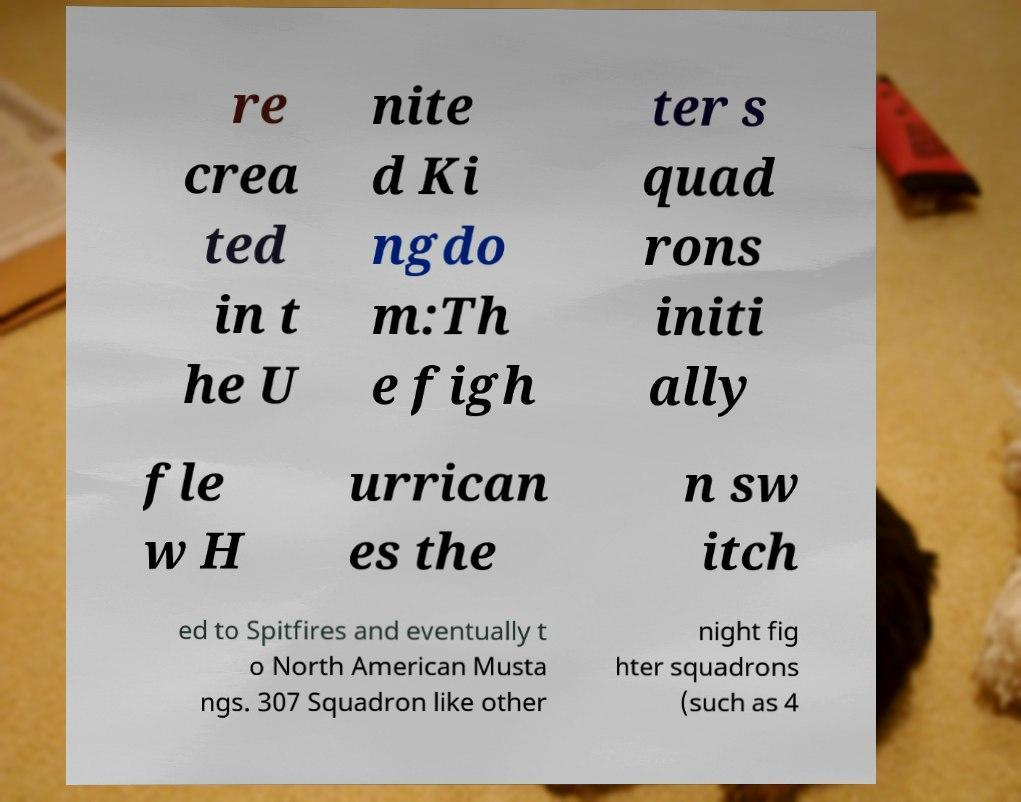Please read and relay the text visible in this image. What does it say? re crea ted in t he U nite d Ki ngdo m:Th e figh ter s quad rons initi ally fle w H urrican es the n sw itch ed to Spitfires and eventually t o North American Musta ngs. 307 Squadron like other night fig hter squadrons (such as 4 